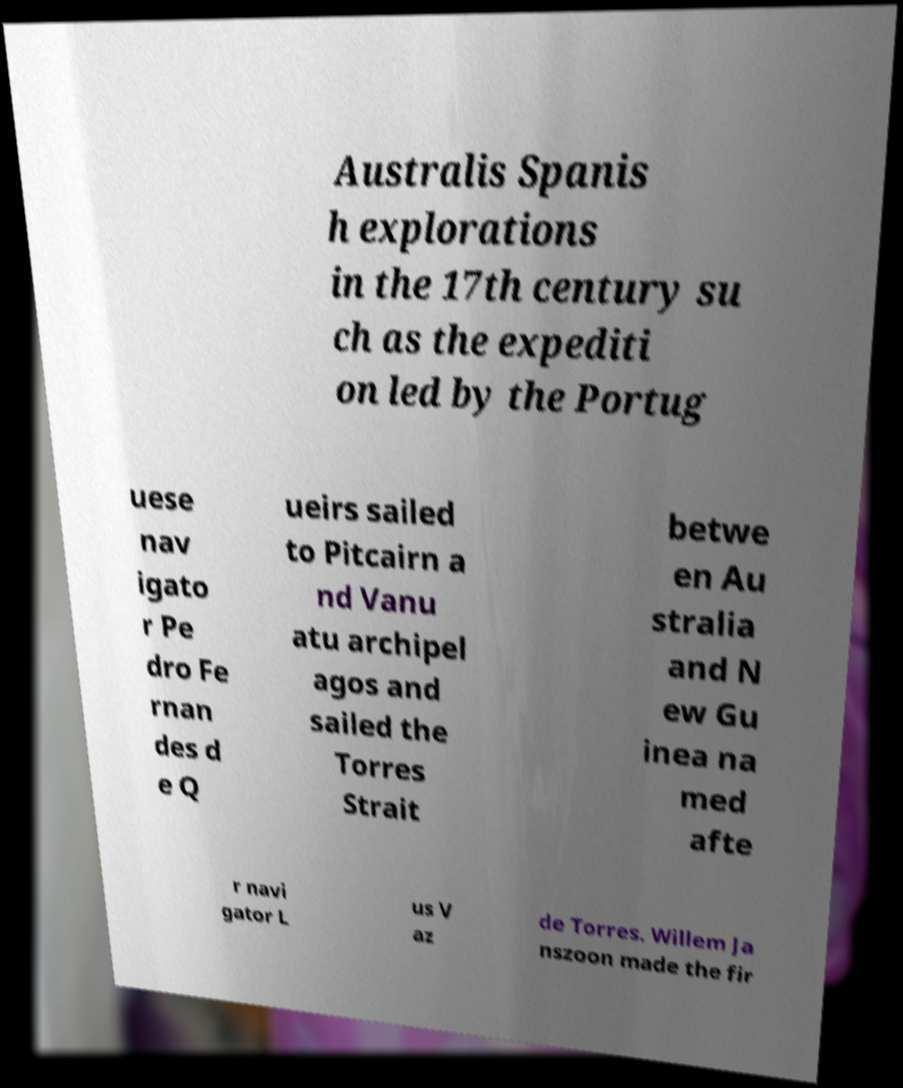Please read and relay the text visible in this image. What does it say? Australis Spanis h explorations in the 17th century su ch as the expediti on led by the Portug uese nav igato r Pe dro Fe rnan des d e Q ueirs sailed to Pitcairn a nd Vanu atu archipel agos and sailed the Torres Strait betwe en Au stralia and N ew Gu inea na med afte r navi gator L us V az de Torres. Willem Ja nszoon made the fir 